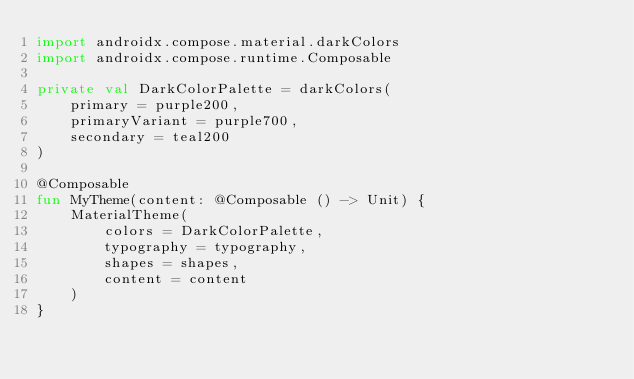<code> <loc_0><loc_0><loc_500><loc_500><_Kotlin_>import androidx.compose.material.darkColors
import androidx.compose.runtime.Composable

private val DarkColorPalette = darkColors(
    primary = purple200,
    primaryVariant = purple700,
    secondary = teal200
)

@Composable
fun MyTheme(content: @Composable () -> Unit) {
    MaterialTheme(
        colors = DarkColorPalette,
        typography = typography,
        shapes = shapes,
        content = content
    )
}
</code> 